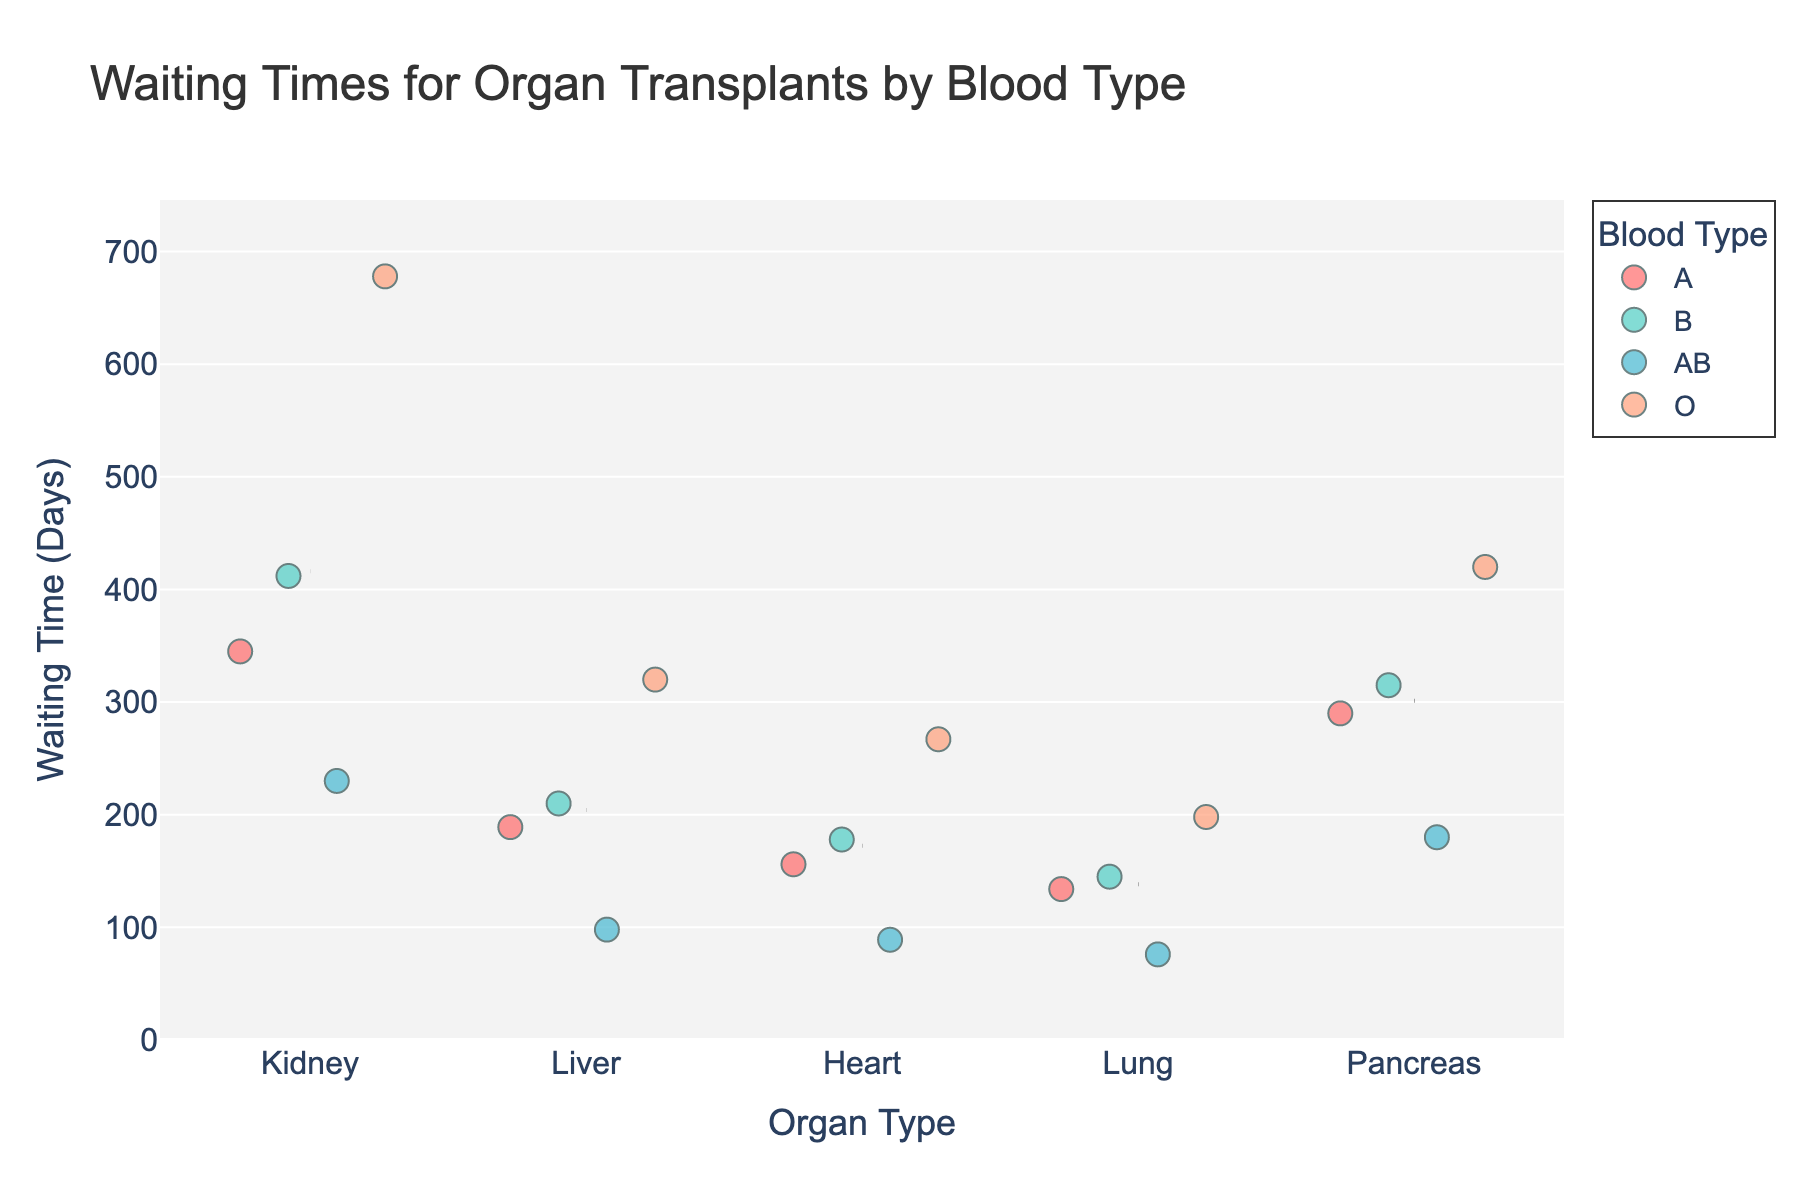What is the title of the plot? The title of the plot is displayed at the top and indicates the content of the plot, which in this case is about the waiting times for organ transplants categorized by blood type.
Answer: Waiting Times for Organ Transplants by Blood Type What are the labels of the axes? The y-axis represents the waiting time in days, and the x-axis represents the organ types. These labels are clearly mentioned along the respective axes.
Answer: Waiting Time (Days) and Organ Type Which blood type has the highest waiting time for a kidney transplant? To determine this, look at the kidney transplant strip plot points and find the waiting time with the highest value. The highest value is the point colored for blood type O.
Answer: Blood type O What is the range of waiting times for heart transplants? Identify the minimum and maximum waiting times for heart transplants. From the plot, the minimum is for blood type AB and the maximum is for blood type O. Subtract these to find the range.
Answer: 178 – 89 = 89 days Which organ has the most consistent waiting times across different blood types? To assess consistency, look for the organ with the least spread in waiting times for different blood types. The liver shows the least variability among all organ transplants.
Answer: Liver How does the average waiting time for a pancreas transplant compare to a liver transplant? Estimate the average waiting time for both pancreas and liver transplants by looking at the mean lines added to the plot. The average time for a pancreas transplant appears higher than that for a liver transplant.
Answer: Pancreas average time is higher What is the average waiting time for lung transplants? To find the average, look at the mean line for lung transplants. This line represents the mean waiting time by aggregating over all blood types.
Answer: Roughly around 138 days Which organ has the longest waiting time for blood type B? Examine where the waiting time for blood type B (colored accordingly) is the highest, and identify the corresponding organ. Pancreas and Kidney have high waiting times, but Kidney is slightly higher.
Answer: Kidney Is the waiting time generally higher for blood type O compared to other blood types across all organs? Compare the waiting times for blood type O (colored accordingly) against other blood types across all organs. Blood type O generally shows higher waiting times for most organs.
Answer: Yes 